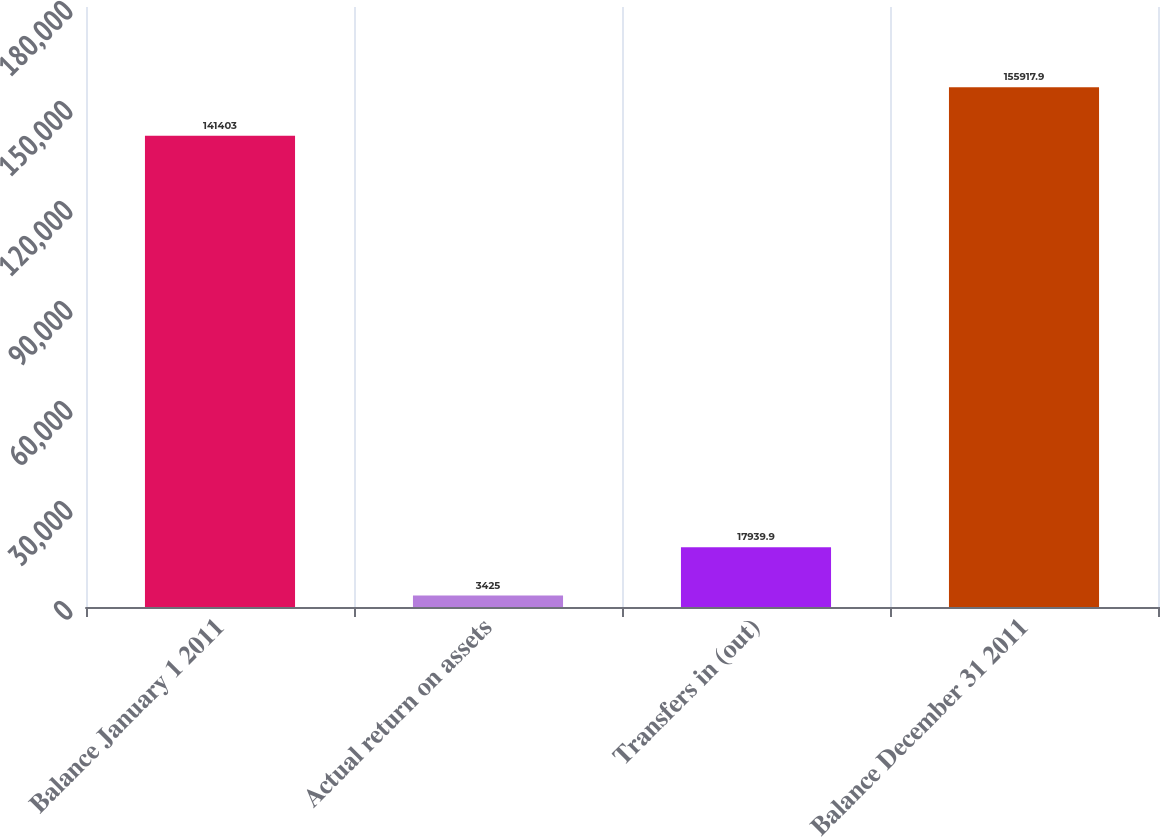<chart> <loc_0><loc_0><loc_500><loc_500><bar_chart><fcel>Balance January 1 2011<fcel>Actual return on assets<fcel>Transfers in (out)<fcel>Balance December 31 2011<nl><fcel>141403<fcel>3425<fcel>17939.9<fcel>155918<nl></chart> 